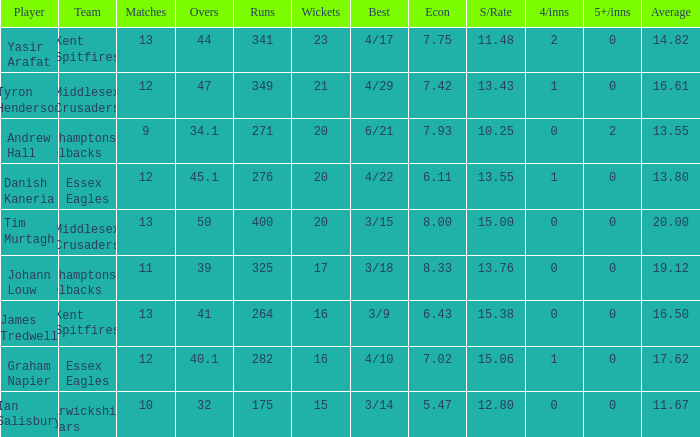Which games are associated with the 17th wicket? 11.0. 